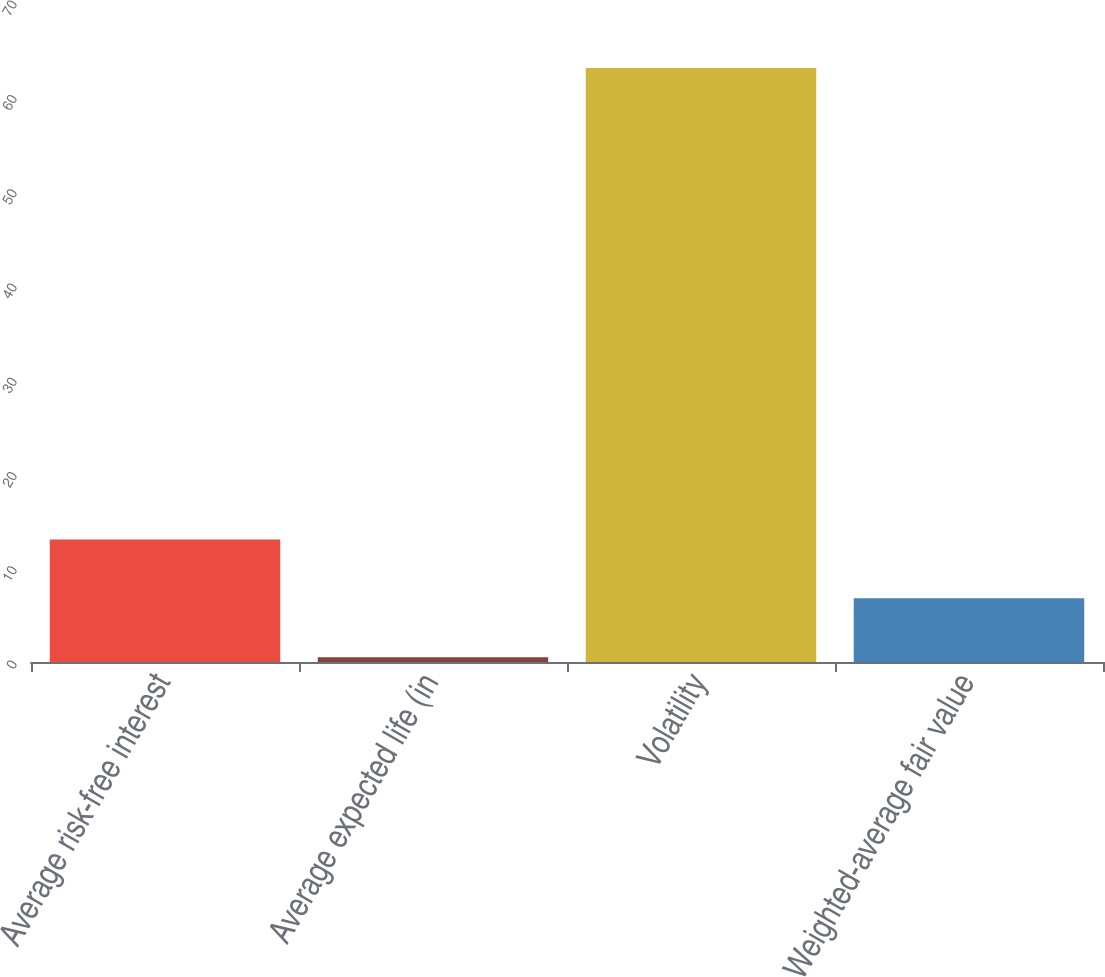Convert chart to OTSL. <chart><loc_0><loc_0><loc_500><loc_500><bar_chart><fcel>Average risk-free interest<fcel>Average expected life (in<fcel>Volatility<fcel>Weighted-average fair value<nl><fcel>13<fcel>0.5<fcel>63<fcel>6.75<nl></chart> 